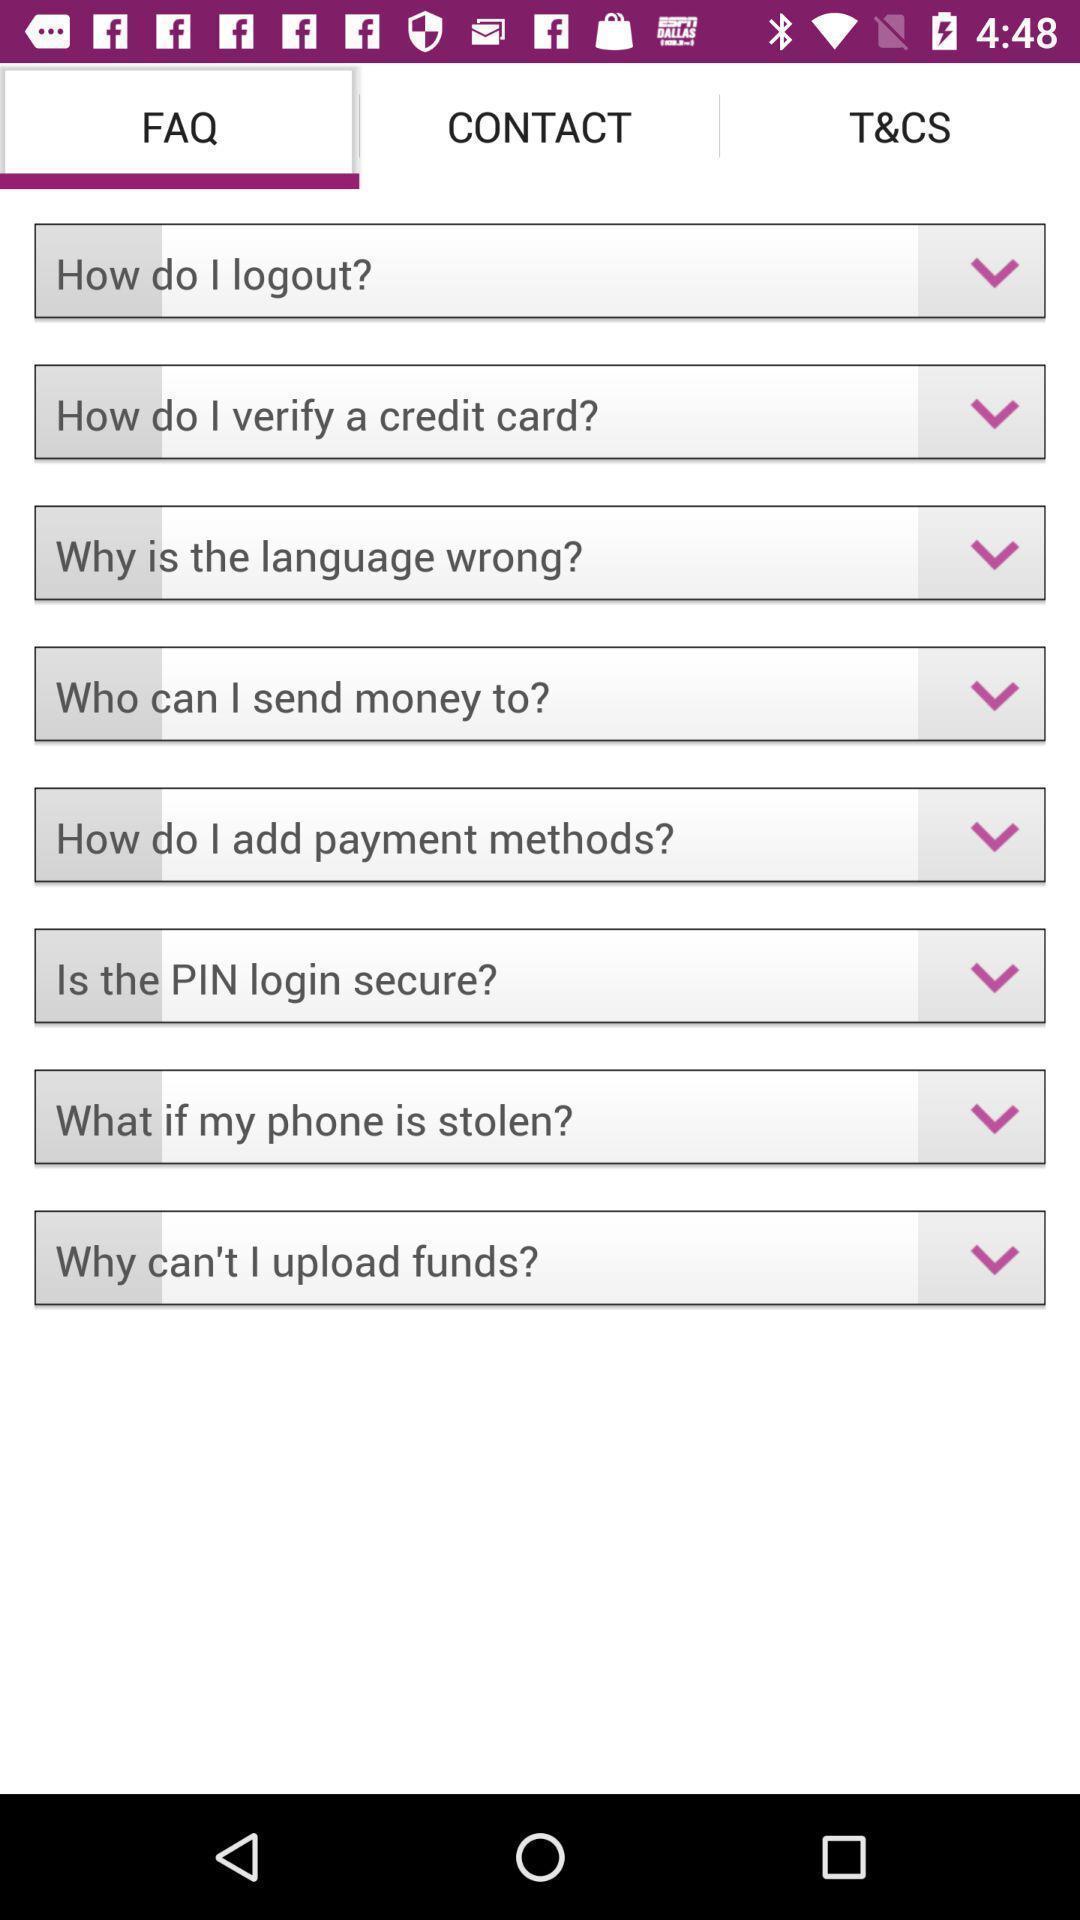Tell me about the visual elements in this screen capture. Screen displaying the list of faq. 